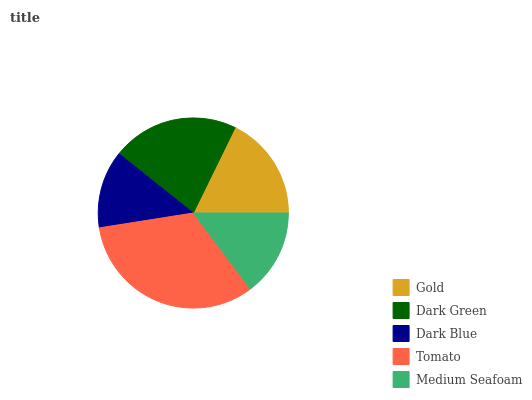Is Dark Blue the minimum?
Answer yes or no. Yes. Is Tomato the maximum?
Answer yes or no. Yes. Is Dark Green the minimum?
Answer yes or no. No. Is Dark Green the maximum?
Answer yes or no. No. Is Dark Green greater than Gold?
Answer yes or no. Yes. Is Gold less than Dark Green?
Answer yes or no. Yes. Is Gold greater than Dark Green?
Answer yes or no. No. Is Dark Green less than Gold?
Answer yes or no. No. Is Gold the high median?
Answer yes or no. Yes. Is Gold the low median?
Answer yes or no. Yes. Is Dark Blue the high median?
Answer yes or no. No. Is Dark Blue the low median?
Answer yes or no. No. 